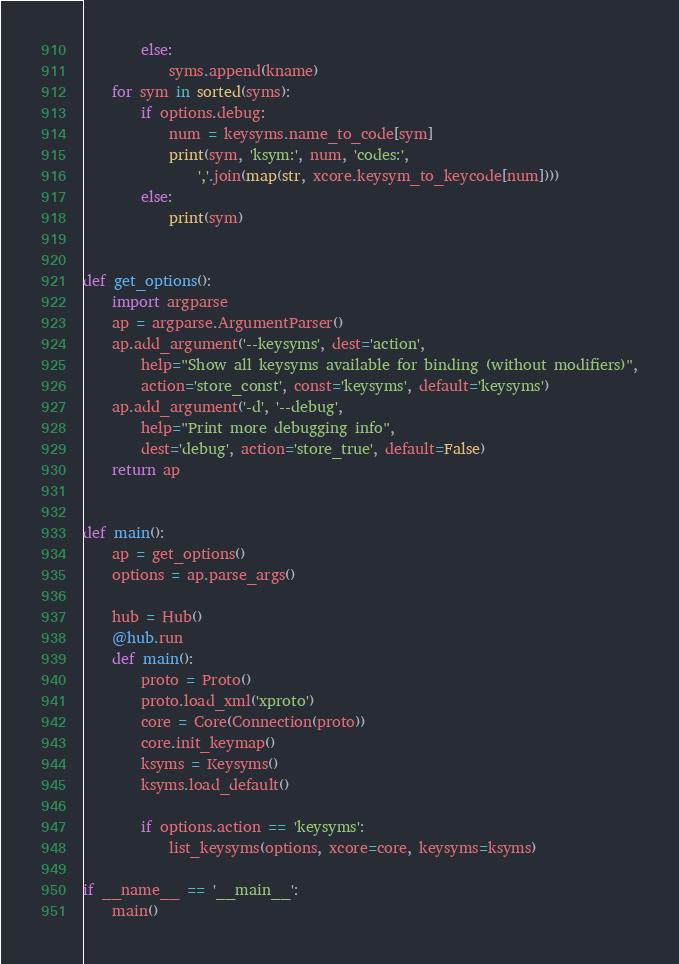<code> <loc_0><loc_0><loc_500><loc_500><_Python_>        else:
            syms.append(kname)
    for sym in sorted(syms):
        if options.debug:
            num = keysyms.name_to_code[sym]
            print(sym, 'ksym:', num, 'codes:',
                ','.join(map(str, xcore.keysym_to_keycode[num])))
        else:
            print(sym)


def get_options():
    import argparse
    ap = argparse.ArgumentParser()
    ap.add_argument('--keysyms', dest='action',
        help="Show all keysyms available for binding (without modifiers)",
        action='store_const', const='keysyms', default='keysyms')
    ap.add_argument('-d', '--debug',
        help="Print more debugging info",
        dest='debug', action='store_true', default=False)
    return ap


def main():
    ap = get_options()
    options = ap.parse_args()

    hub = Hub()
    @hub.run
    def main():
        proto = Proto()
        proto.load_xml('xproto')
        core = Core(Connection(proto))
        core.init_keymap()
        ksyms = Keysyms()
        ksyms.load_default()

        if options.action == 'keysyms':
            list_keysyms(options, xcore=core, keysyms=ksyms)

if __name__ == '__main__':
    main()
</code> 